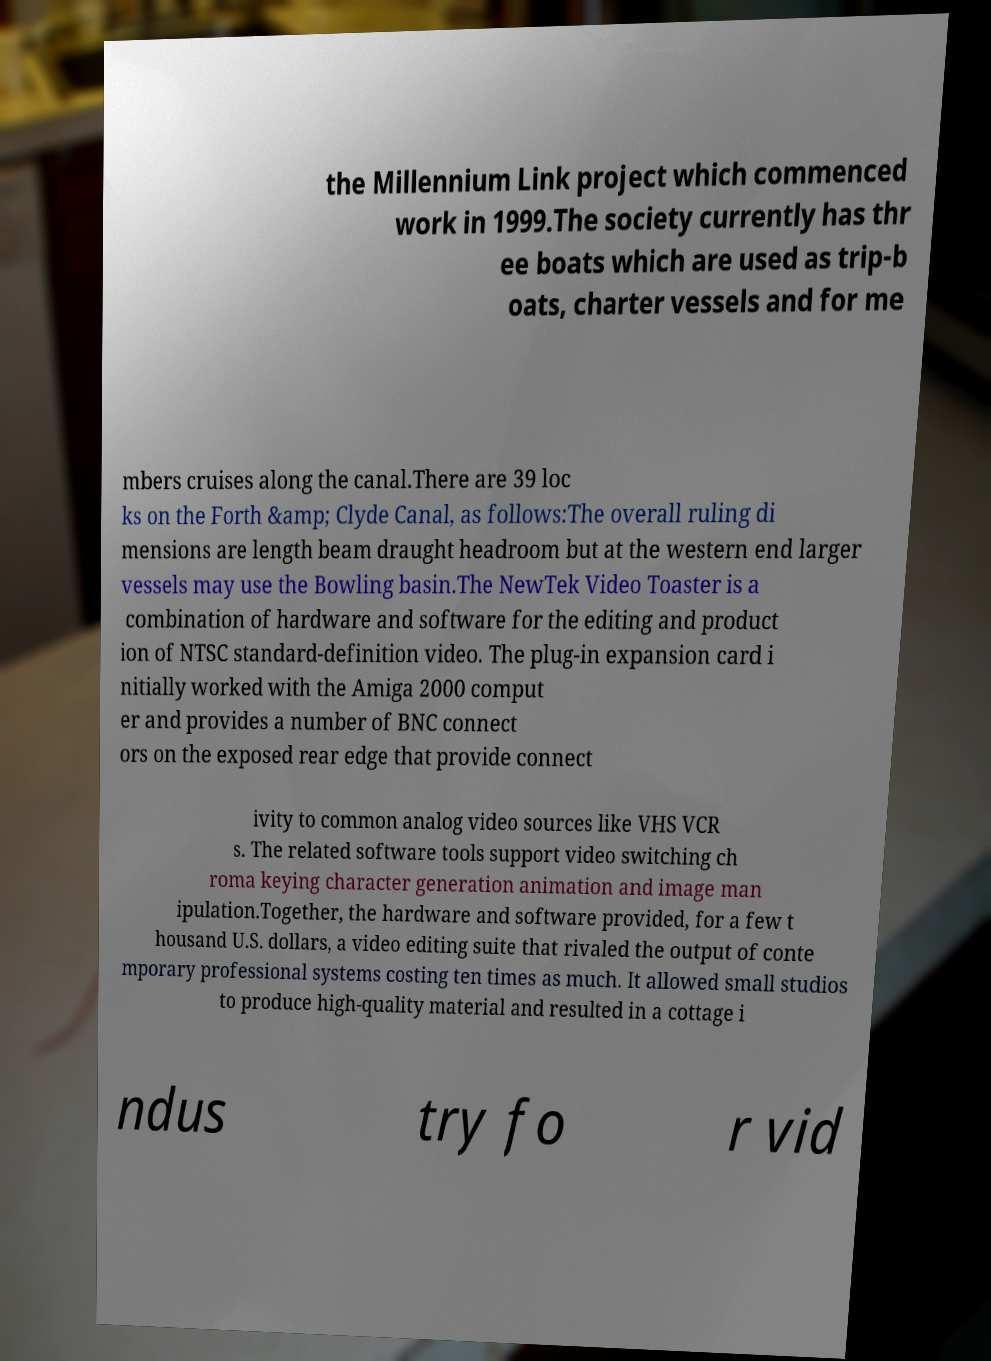I need the written content from this picture converted into text. Can you do that? the Millennium Link project which commenced work in 1999.The society currently has thr ee boats which are used as trip-b oats, charter vessels and for me mbers cruises along the canal.There are 39 loc ks on the Forth &amp; Clyde Canal, as follows:The overall ruling di mensions are length beam draught headroom but at the western end larger vessels may use the Bowling basin.The NewTek Video Toaster is a combination of hardware and software for the editing and product ion of NTSC standard-definition video. The plug-in expansion card i nitially worked with the Amiga 2000 comput er and provides a number of BNC connect ors on the exposed rear edge that provide connect ivity to common analog video sources like VHS VCR s. The related software tools support video switching ch roma keying character generation animation and image man ipulation.Together, the hardware and software provided, for a few t housand U.S. dollars, a video editing suite that rivaled the output of conte mporary professional systems costing ten times as much. It allowed small studios to produce high-quality material and resulted in a cottage i ndus try fo r vid 